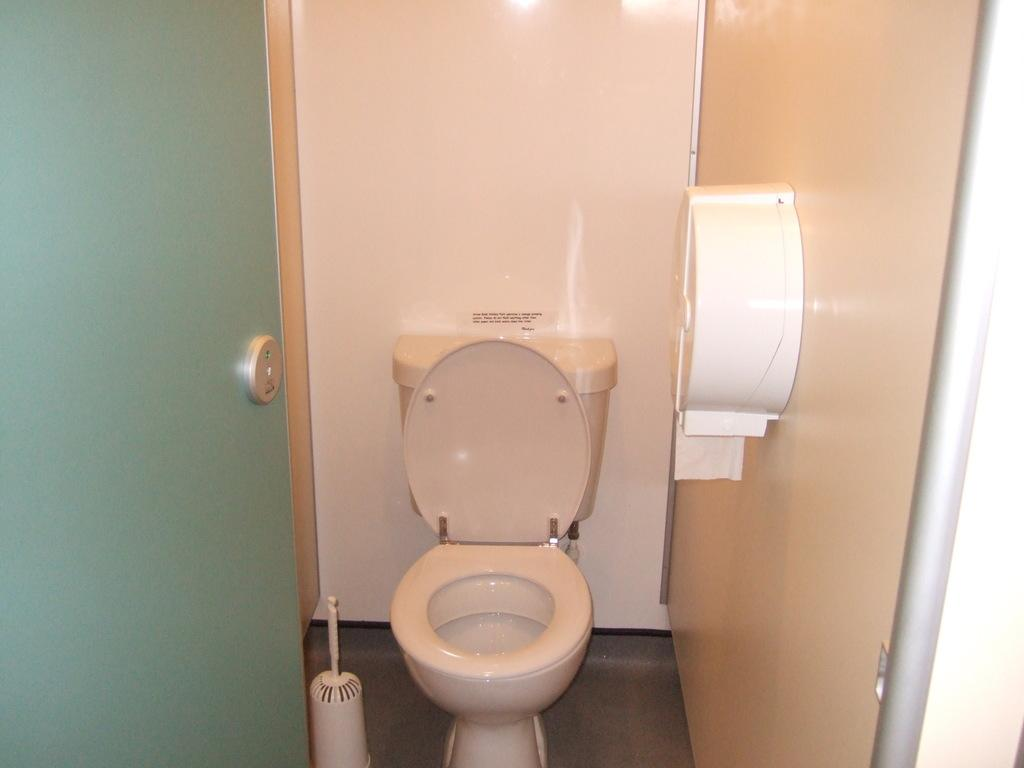What is the main object in the image? There is a toilet seat in the image. Can you describe any other objects or features in the image? There is a door and a wall with a white object attached to it in the image. What type of army equipment can be seen in the image? There is no army equipment present in the image. What type of stove is visible in the image? There is no stove present in the image. 